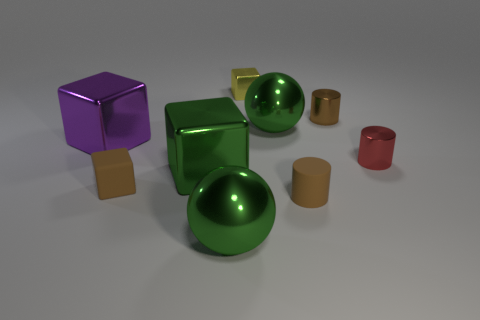There is a tiny matte thing that is the same color as the tiny rubber cube; what is its shape?
Keep it short and to the point. Cylinder. What size is the shiny cylinder that is the same color as the rubber cube?
Your answer should be compact. Small. Does the brown shiny thing have the same size as the purple block?
Ensure brevity in your answer.  No. What number of cylinders are tiny metallic things or large things?
Your answer should be compact. 2. What is the material of the other cylinder that is the same color as the rubber cylinder?
Offer a terse response. Metal. Does the matte object that is right of the brown matte block have the same shape as the big object that is in front of the brown matte cylinder?
Provide a short and direct response. No. What color is the metallic cube that is both on the right side of the rubber block and in front of the yellow thing?
Ensure brevity in your answer.  Green. There is a rubber cylinder; is it the same color as the tiny object left of the small yellow thing?
Your answer should be compact. Yes. How big is the brown thing that is both on the left side of the brown metal cylinder and to the right of the green cube?
Offer a terse response. Small. How many other things are there of the same color as the matte cube?
Your answer should be compact. 2. 